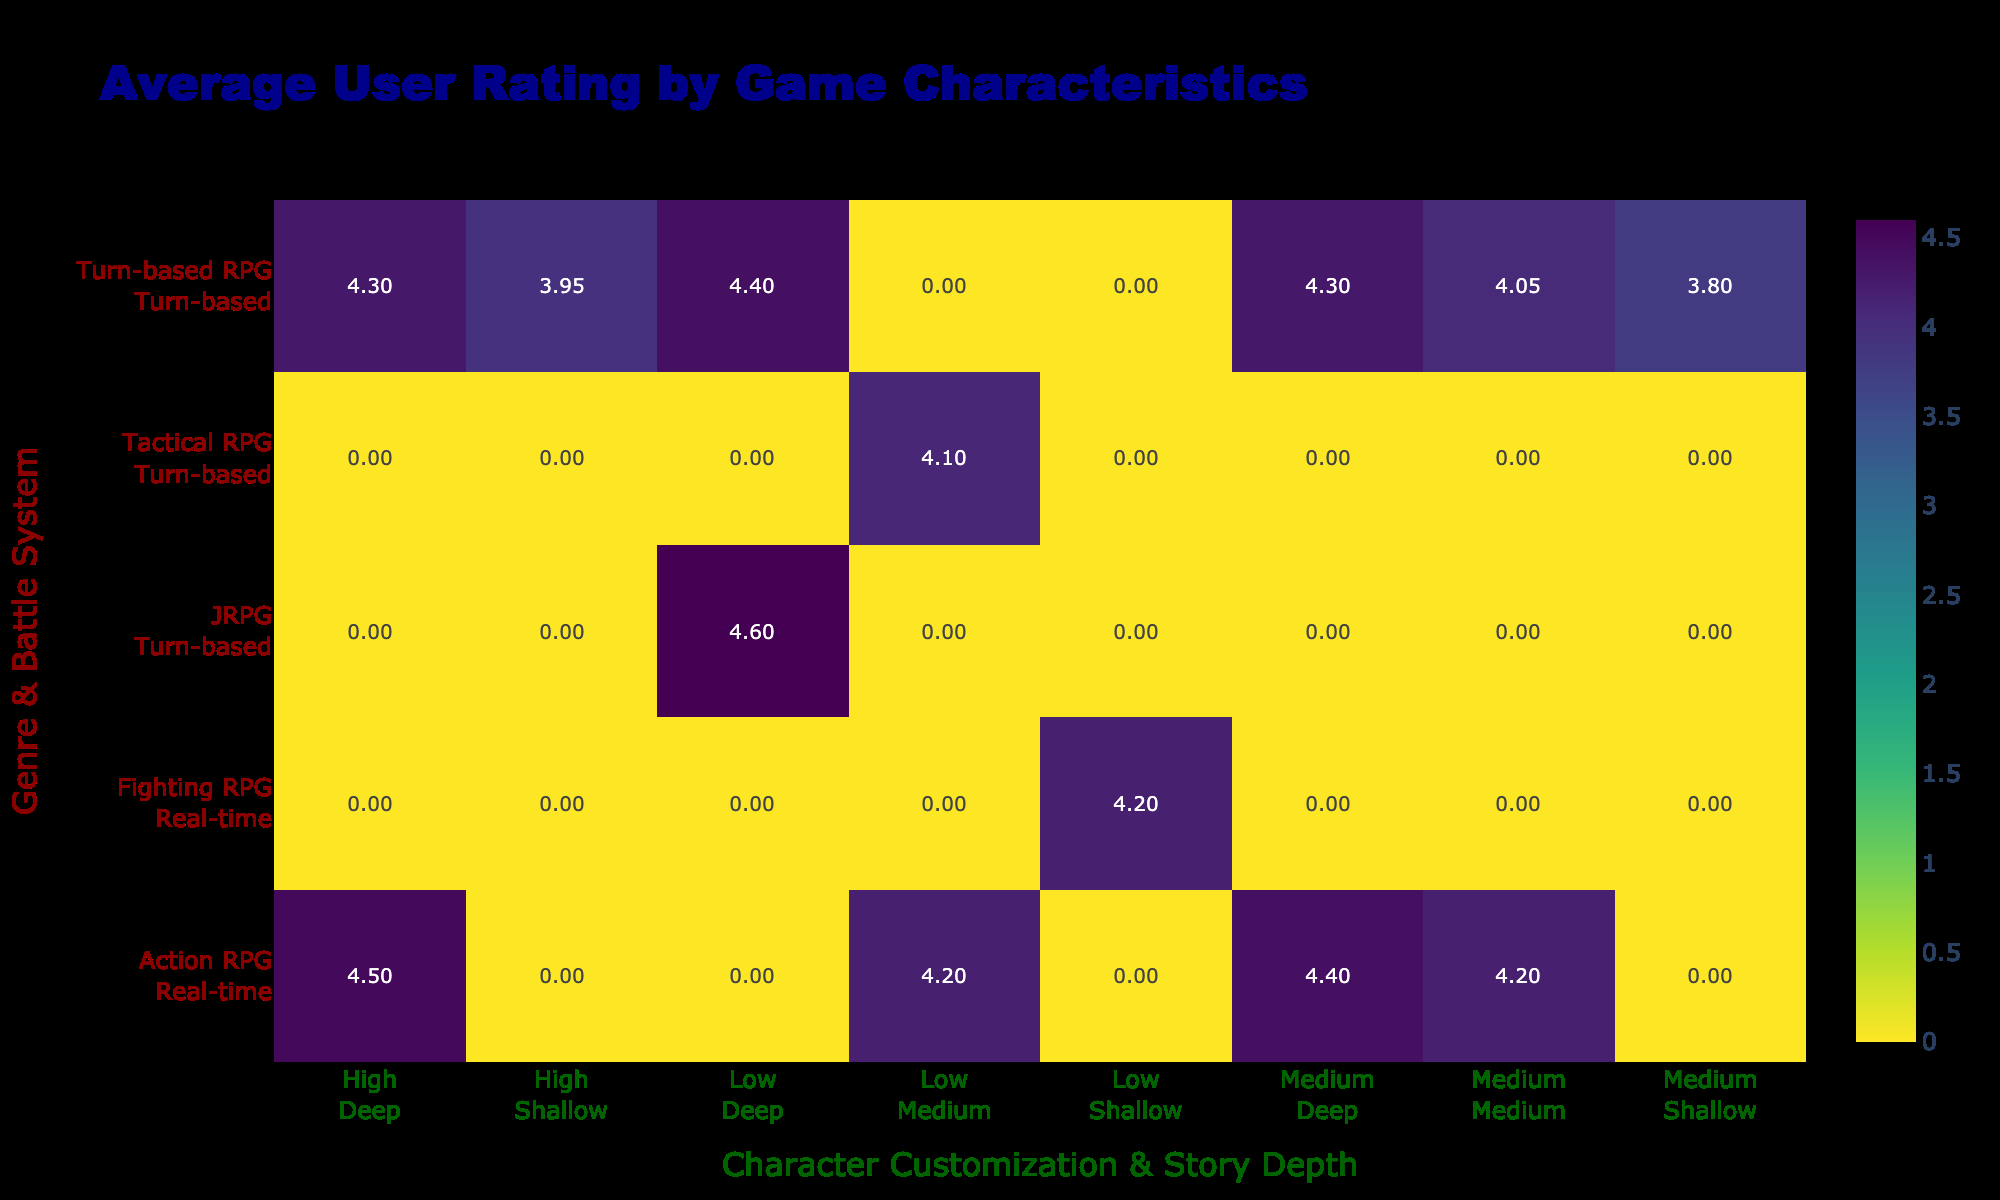What is the highest average user rating for any game in the table? The highest average user rating can be found by scanning through the table for the highest value. The highest value found is 4.6, attributed to "Another Eden" which falls under the JRPG genre with a turn-based battle system, low character customization, and deep story depth.
Answer: 4.6 How many games feature a real-time battle system with high character customization? By examining the entries with a real-time battle system and high character customization, we can see that only "Genshin Impact" and "Honkai Impact 3rd" meet these criteria. Therefore, there are 2 such games.
Answer: 2 Are there any games that are labeled as fighting RPGs with a deep story? Looking through the table, "MARVEL Contest of Champions" is the only fighting RPG listed, and it is categorized as having a shallow story depth. This indicates that there are no fighting RPGs with a deep story in the table.
Answer: No What is the average user rating for turn-based RPGs with medium story depth? To calculate this, we first identify the turn-based RPGs with medium story depth: "Final Fantasy Brave Exvius," "Star Wars: Galaxy of Heroes," and "The Seven Deadly Sins: Grand Cross." Their user ratings are 4.3, 4.0, and 4.1, respectively. The total of these ratings is 4.3 + 4.0 + 4.1 = 12.4. To find the average, we divide by the number of games: 12.4 / 3 = 4.13.
Answer: 4.13 Which genre has the highest overall performance based on user ratings for turn-based RPGs? We should calculate the average user rating for each genre's turn-based RPGs. For turn-based RPGs in this table, the ratings are as follows: Fate/Grand Order (4.4), Epic Seven (4.3), Final Fantasy Brave Exvius (4.3), Raid: Shadow Legends (3.9), and others. The overall average is (4.4 + 4.3 + 4.3 + 3.9 + 4.1 + 3.8 + 4.0) / 7 = 4.1. This indicates that the turn-based RPG genre holds an average of 4.1 for the listed games.
Answer: 4.1 How many games in the table have low character customization but deep story depth? Evaluating the entries, "Fate/Grand Order," "Another Eden," and "Genshin Impact" provide deep story depth with low character customization. Thus, we find that there are 2 games fitting this description: "Fate/Grand Order" and "Another Eden."
Answer: 2 